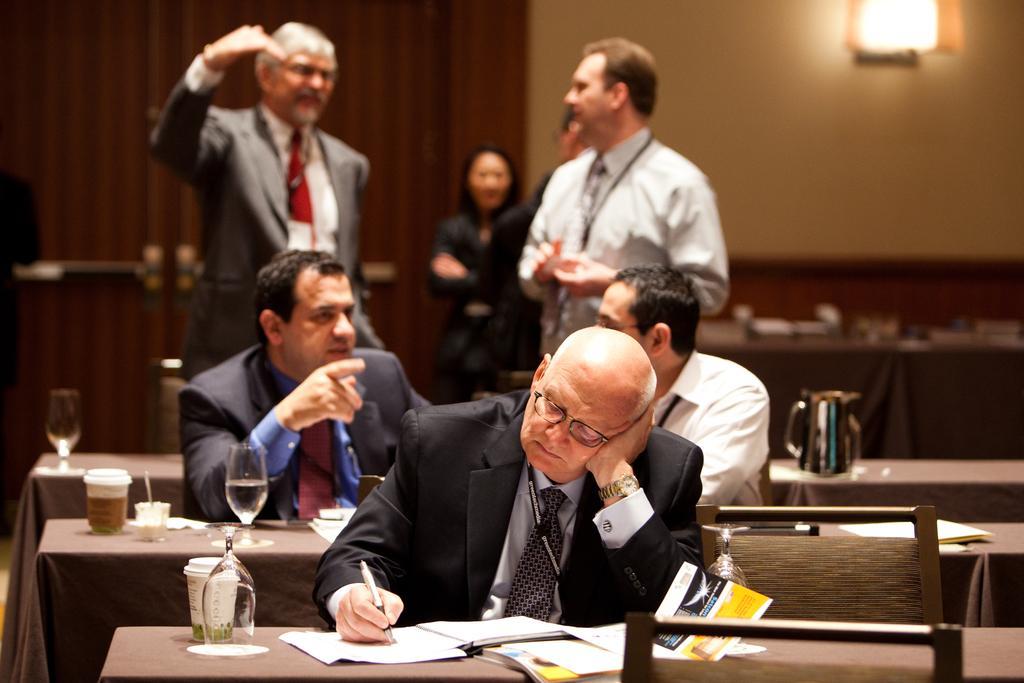How would you summarize this image in a sentence or two? These three persons are sitting on chair. In-front of them there are table, on this table there are glasses, cups, book and papers. Front this man wore suit, spectacles and holding a pen. Far this persons are standing. A light is on wall. 